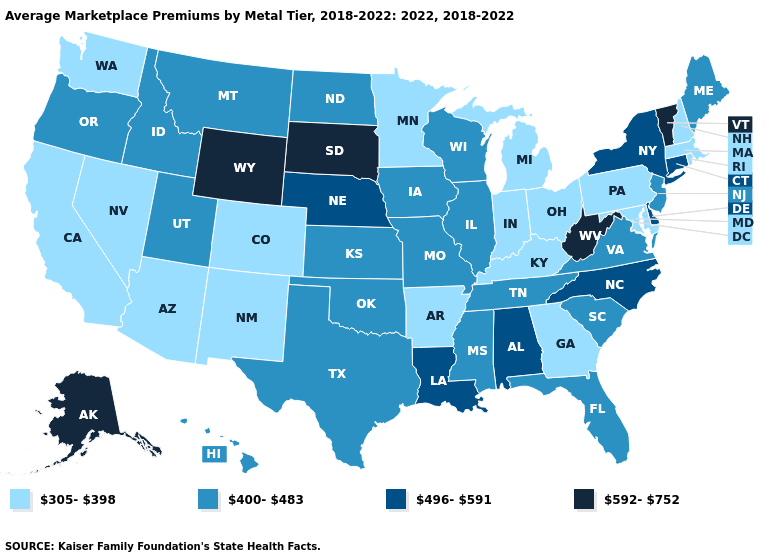What is the lowest value in the Northeast?
Concise answer only. 305-398. Name the states that have a value in the range 400-483?
Concise answer only. Florida, Hawaii, Idaho, Illinois, Iowa, Kansas, Maine, Mississippi, Missouri, Montana, New Jersey, North Dakota, Oklahoma, Oregon, South Carolina, Tennessee, Texas, Utah, Virginia, Wisconsin. Which states hav the highest value in the MidWest?
Concise answer only. South Dakota. Name the states that have a value in the range 400-483?
Give a very brief answer. Florida, Hawaii, Idaho, Illinois, Iowa, Kansas, Maine, Mississippi, Missouri, Montana, New Jersey, North Dakota, Oklahoma, Oregon, South Carolina, Tennessee, Texas, Utah, Virginia, Wisconsin. What is the value of South Carolina?
Keep it brief. 400-483. What is the value of Tennessee?
Be succinct. 400-483. What is the value of Tennessee?
Quick response, please. 400-483. What is the value of Iowa?
Answer briefly. 400-483. What is the lowest value in states that border Connecticut?
Be succinct. 305-398. What is the value of Texas?
Quick response, please. 400-483. Does Maine have a lower value than Nebraska?
Quick response, please. Yes. Name the states that have a value in the range 592-752?
Quick response, please. Alaska, South Dakota, Vermont, West Virginia, Wyoming. Does Connecticut have the lowest value in the USA?
Quick response, please. No. Which states hav the highest value in the MidWest?
Quick response, please. South Dakota. Is the legend a continuous bar?
Write a very short answer. No. 